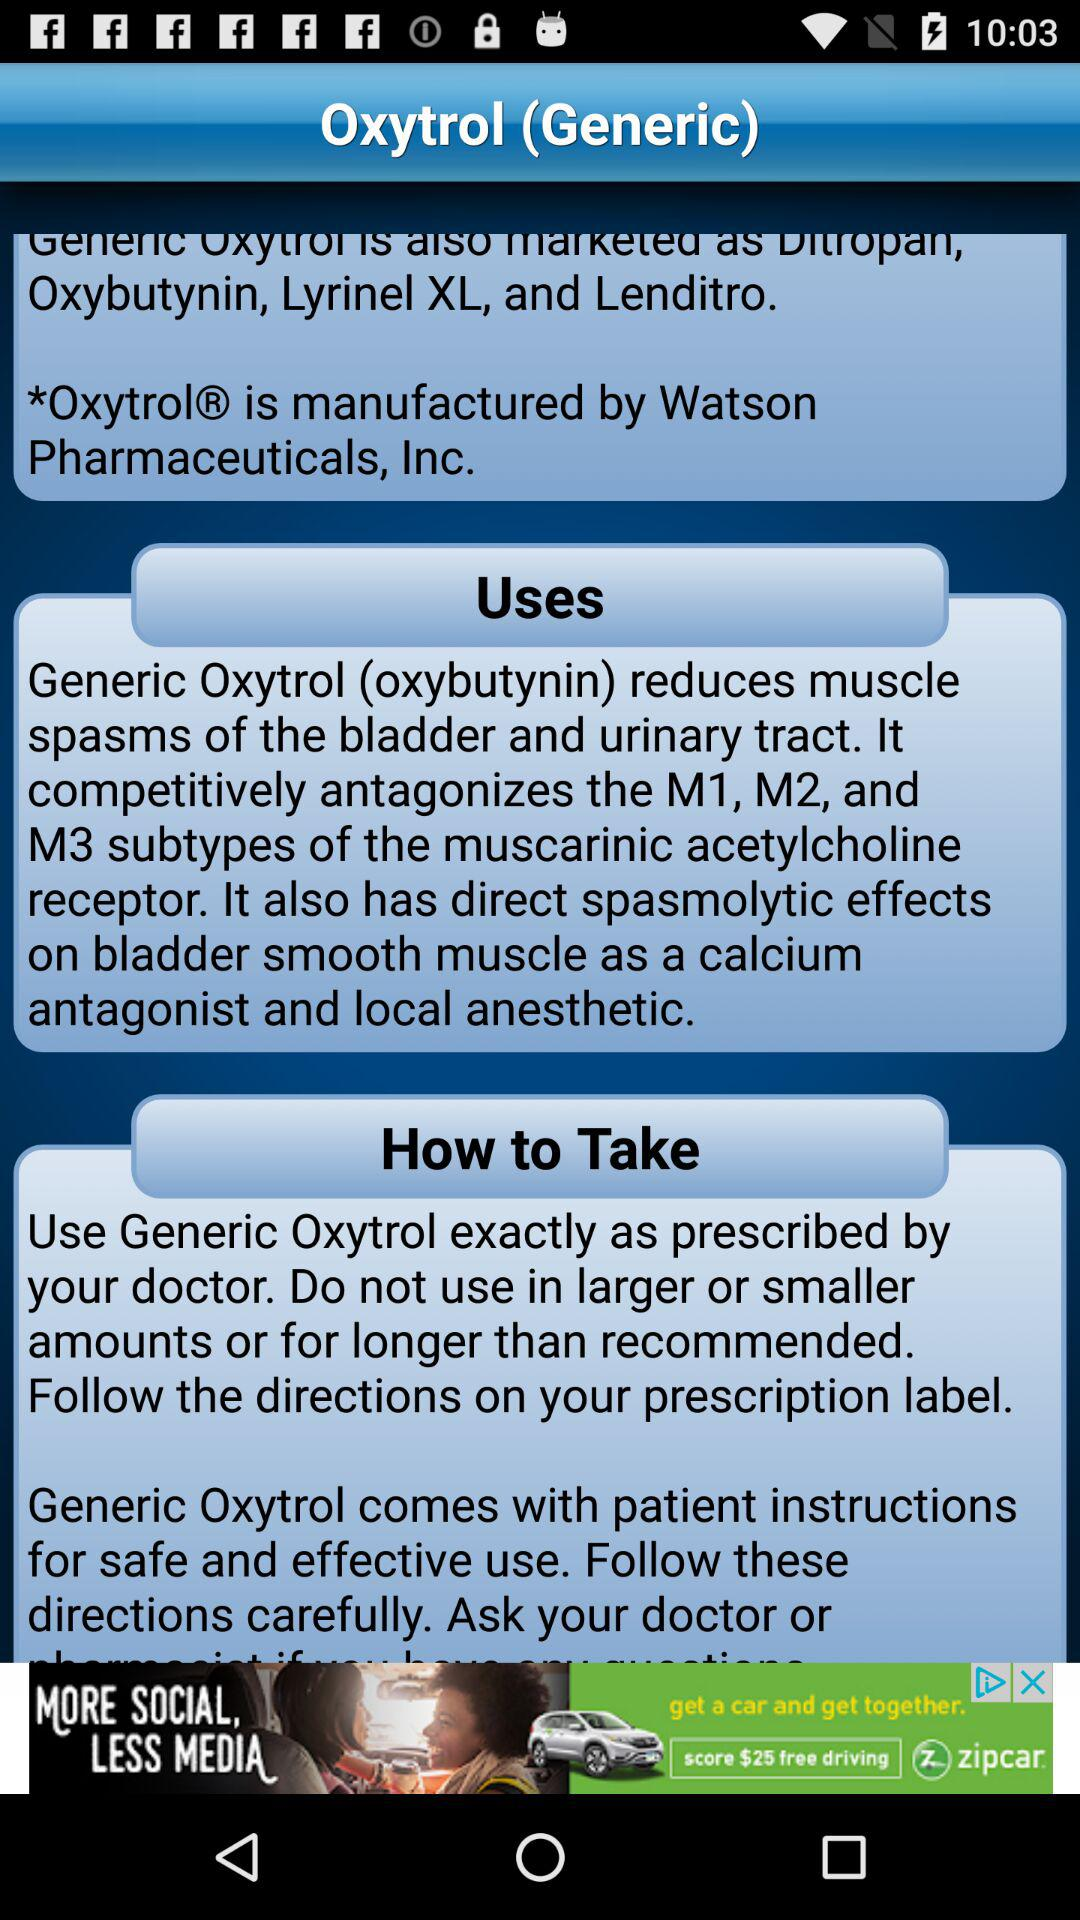Who is manufacturing oxytrol? Oxytrol is manufactured by "Watson Pharmaceuticals, Inc.". 